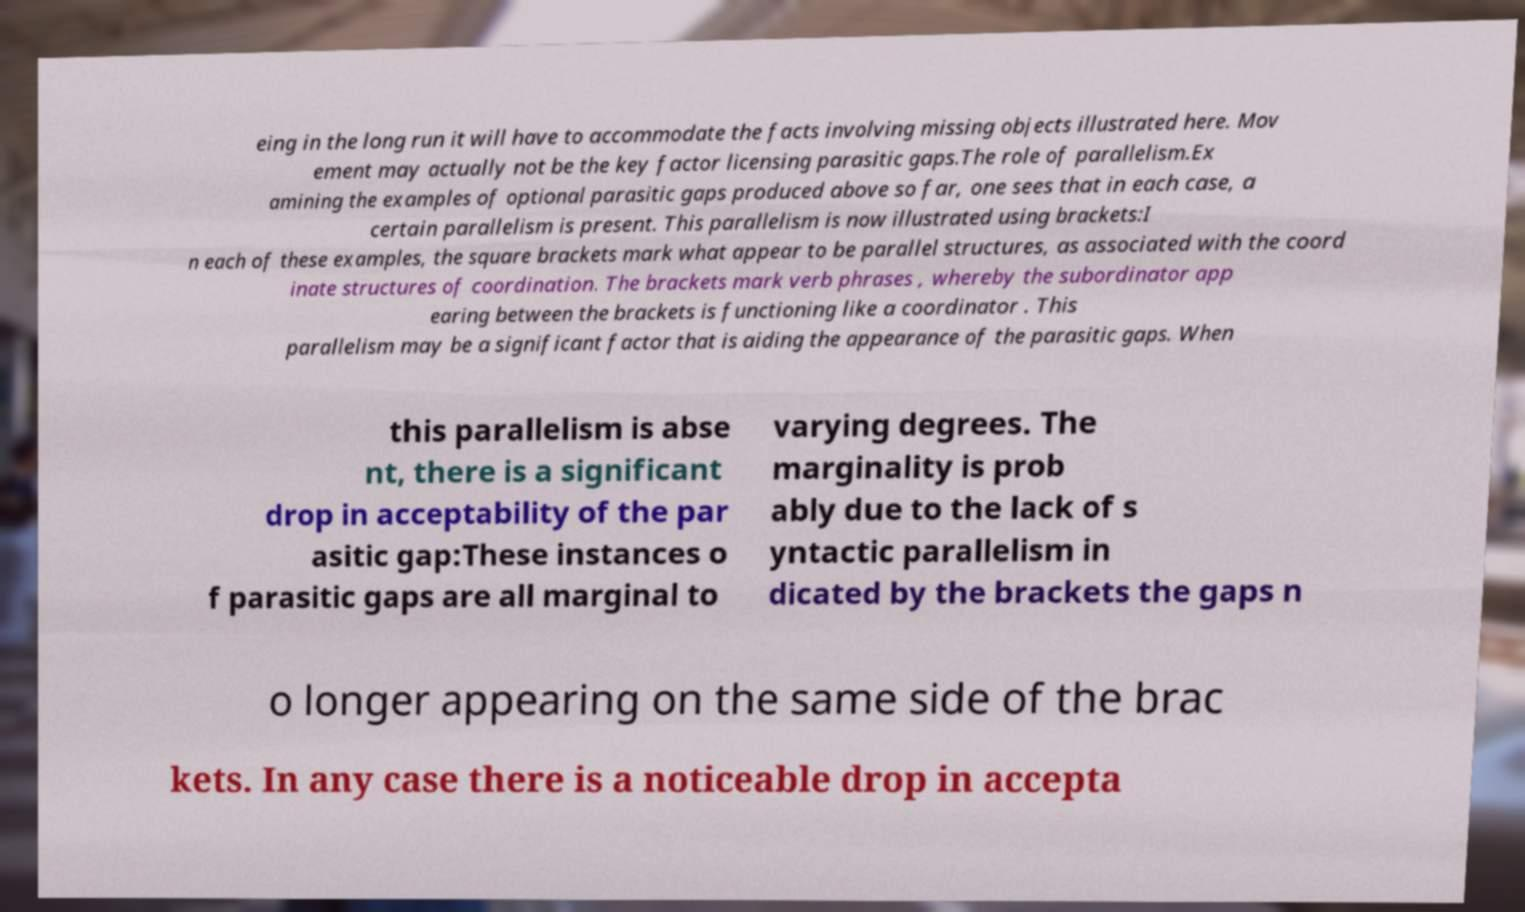There's text embedded in this image that I need extracted. Can you transcribe it verbatim? eing in the long run it will have to accommodate the facts involving missing objects illustrated here. Mov ement may actually not be the key factor licensing parasitic gaps.The role of parallelism.Ex amining the examples of optional parasitic gaps produced above so far, one sees that in each case, a certain parallelism is present. This parallelism is now illustrated using brackets:I n each of these examples, the square brackets mark what appear to be parallel structures, as associated with the coord inate structures of coordination. The brackets mark verb phrases , whereby the subordinator app earing between the brackets is functioning like a coordinator . This parallelism may be a significant factor that is aiding the appearance of the parasitic gaps. When this parallelism is abse nt, there is a significant drop in acceptability of the par asitic gap:These instances o f parasitic gaps are all marginal to varying degrees. The marginality is prob ably due to the lack of s yntactic parallelism in dicated by the brackets the gaps n o longer appearing on the same side of the brac kets. In any case there is a noticeable drop in accepta 